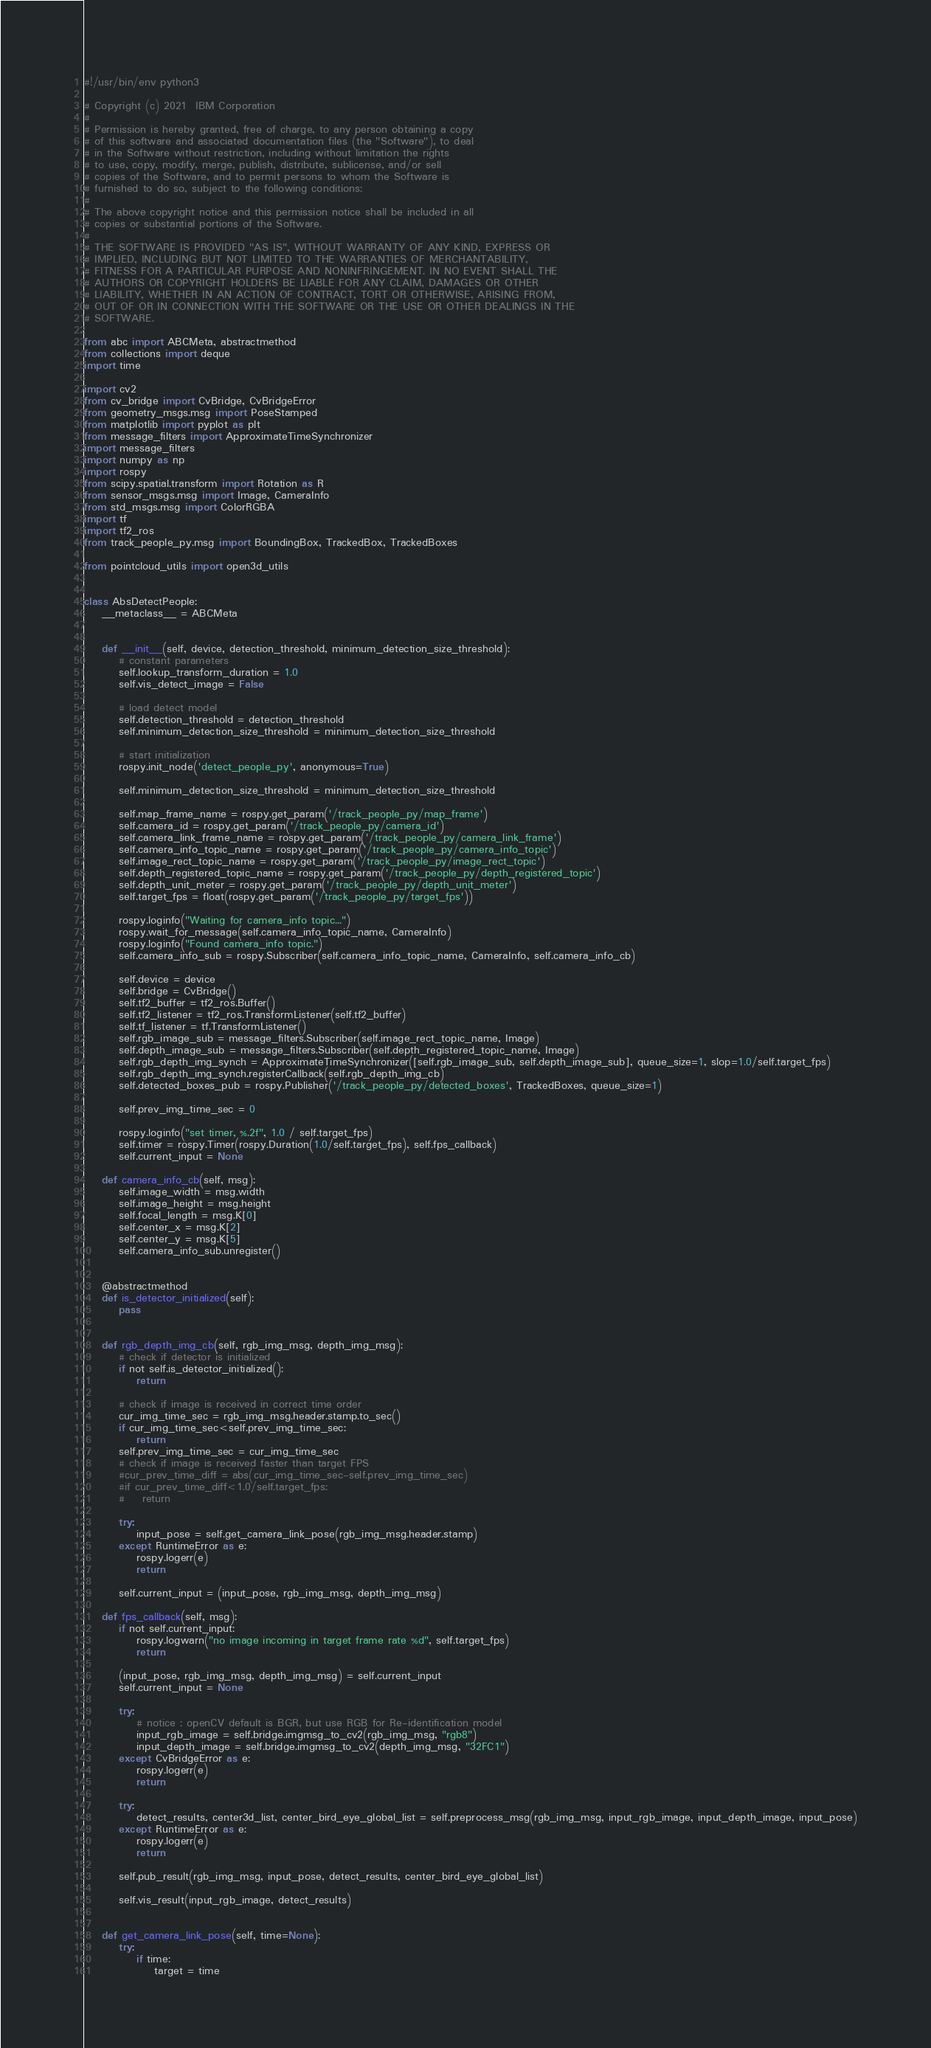<code> <loc_0><loc_0><loc_500><loc_500><_Python_>#!/usr/bin/env python3

# Copyright (c) 2021  IBM Corporation
#
# Permission is hereby granted, free of charge, to any person obtaining a copy
# of this software and associated documentation files (the "Software"), to deal
# in the Software without restriction, including without limitation the rights
# to use, copy, modify, merge, publish, distribute, sublicense, and/or sell
# copies of the Software, and to permit persons to whom the Software is
# furnished to do so, subject to the following conditions:
#
# The above copyright notice and this permission notice shall be included in all
# copies or substantial portions of the Software.
#
# THE SOFTWARE IS PROVIDED "AS IS", WITHOUT WARRANTY OF ANY KIND, EXPRESS OR
# IMPLIED, INCLUDING BUT NOT LIMITED TO THE WARRANTIES OF MERCHANTABILITY,
# FITNESS FOR A PARTICULAR PURPOSE AND NONINFRINGEMENT. IN NO EVENT SHALL THE
# AUTHORS OR COPYRIGHT HOLDERS BE LIABLE FOR ANY CLAIM, DAMAGES OR OTHER
# LIABILITY, WHETHER IN AN ACTION OF CONTRACT, TORT OR OTHERWISE, ARISING FROM,
# OUT OF OR IN CONNECTION WITH THE SOFTWARE OR THE USE OR OTHER DEALINGS IN THE
# SOFTWARE.

from abc import ABCMeta, abstractmethod
from collections import deque
import time

import cv2
from cv_bridge import CvBridge, CvBridgeError
from geometry_msgs.msg import PoseStamped
from matplotlib import pyplot as plt
from message_filters import ApproximateTimeSynchronizer
import message_filters
import numpy as np
import rospy
from scipy.spatial.transform import Rotation as R
from sensor_msgs.msg import Image, CameraInfo
from std_msgs.msg import ColorRGBA
import tf
import tf2_ros
from track_people_py.msg import BoundingBox, TrackedBox, TrackedBoxes

from pointcloud_utils import open3d_utils


class AbsDetectPeople:
    __metaclass__ = ABCMeta
    
    
    def __init__(self, device, detection_threshold, minimum_detection_size_threshold):
        # constant parameters
        self.lookup_transform_duration = 1.0
        self.vis_detect_image = False
        
        # load detect model
        self.detection_threshold = detection_threshold
        self.minimum_detection_size_threshold = minimum_detection_size_threshold
        
        # start initialization
        rospy.init_node('detect_people_py', anonymous=True)
        
        self.minimum_detection_size_threshold = minimum_detection_size_threshold
        
        self.map_frame_name = rospy.get_param('/track_people_py/map_frame')
        self.camera_id = rospy.get_param('/track_people_py/camera_id')
        self.camera_link_frame_name = rospy.get_param('/track_people_py/camera_link_frame')
        self.camera_info_topic_name = rospy.get_param('/track_people_py/camera_info_topic')
        self.image_rect_topic_name = rospy.get_param('/track_people_py/image_rect_topic')
        self.depth_registered_topic_name = rospy.get_param('/track_people_py/depth_registered_topic')
        self.depth_unit_meter = rospy.get_param('/track_people_py/depth_unit_meter')
        self.target_fps = float(rospy.get_param('/track_people_py/target_fps'))
        
        rospy.loginfo("Waiting for camera_info topic...")
        rospy.wait_for_message(self.camera_info_topic_name, CameraInfo)
        rospy.loginfo("Found camera_info topic.")
        self.camera_info_sub = rospy.Subscriber(self.camera_info_topic_name, CameraInfo, self.camera_info_cb)
        
        self.device = device
        self.bridge = CvBridge()
        self.tf2_buffer = tf2_ros.Buffer()
        self.tf2_listener = tf2_ros.TransformListener(self.tf2_buffer)
        self.tf_listener = tf.TransformListener()
        self.rgb_image_sub = message_filters.Subscriber(self.image_rect_topic_name, Image)
        self.depth_image_sub = message_filters.Subscriber(self.depth_registered_topic_name, Image)
        self.rgb_depth_img_synch = ApproximateTimeSynchronizer([self.rgb_image_sub, self.depth_image_sub], queue_size=1, slop=1.0/self.target_fps)
        self.rgb_depth_img_synch.registerCallback(self.rgb_depth_img_cb)
        self.detected_boxes_pub = rospy.Publisher('/track_people_py/detected_boxes', TrackedBoxes, queue_size=1)
        
        self.prev_img_time_sec = 0

        rospy.loginfo("set timer, %.2f", 1.0 / self.target_fps)
        self.timer = rospy.Timer(rospy.Duration(1.0/self.target_fps), self.fps_callback)
        self.current_input = None

    def camera_info_cb(self, msg):
        self.image_width = msg.width
        self.image_height = msg.height
        self.focal_length = msg.K[0]
        self.center_x = msg.K[2]
        self.center_y = msg.K[5]
        self.camera_info_sub.unregister()
    
    
    @abstractmethod
    def is_detector_initialized(self):
        pass
    
    
    def rgb_depth_img_cb(self, rgb_img_msg, depth_img_msg):
        # check if detector is initialized
        if not self.is_detector_initialized():
            return
        
        # check if image is received in correct time order
        cur_img_time_sec = rgb_img_msg.header.stamp.to_sec()
        if cur_img_time_sec<self.prev_img_time_sec:
            return
        self.prev_img_time_sec = cur_img_time_sec
        # check if image is received faster than target FPS
        #cur_prev_time_diff = abs(cur_img_time_sec-self.prev_img_time_sec)
        #if cur_prev_time_diff<1.0/self.target_fps:
        #    return
        
        try:
            input_pose = self.get_camera_link_pose(rgb_img_msg.header.stamp)
        except RuntimeError as e:
            rospy.logerr(e)
            return

        self.current_input = (input_pose, rgb_img_msg, depth_img_msg)

    def fps_callback(self, msg):
        if not self.current_input:
            rospy.logwarn("no image incoming in target frame rate %d", self.target_fps)
            return

        (input_pose, rgb_img_msg, depth_img_msg) = self.current_input
        self.current_input = None
        
        try:
            # notice : openCV default is BGR, but use RGB for Re-identification model
            input_rgb_image = self.bridge.imgmsg_to_cv2(rgb_img_msg, "rgb8")
            input_depth_image = self.bridge.imgmsg_to_cv2(depth_img_msg, "32FC1")
        except CvBridgeError as e:
            rospy.logerr(e)
            return

        try:
            detect_results, center3d_list, center_bird_eye_global_list = self.preprocess_msg(rgb_img_msg, input_rgb_image, input_depth_image, input_pose)
        except RuntimeError as e:
            rospy.logerr(e)
            return
        
        self.pub_result(rgb_img_msg, input_pose, detect_results, center_bird_eye_global_list)
        
        self.vis_result(input_rgb_image, detect_results)
    
    
    def get_camera_link_pose(self, time=None):
        try:
            if time:
                target = time</code> 